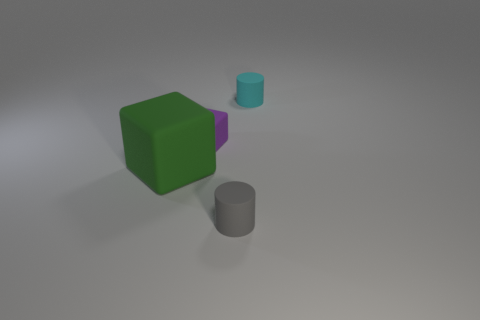Add 1 tiny metallic balls. How many objects exist? 5 Subtract 2 blocks. How many blocks are left? 0 Subtract all purple cylinders. Subtract all yellow blocks. How many cylinders are left? 2 Subtract all gray cylinders. How many green blocks are left? 1 Subtract all tiny cyan rubber cylinders. Subtract all large gray shiny cylinders. How many objects are left? 3 Add 4 cyan matte things. How many cyan matte things are left? 5 Add 3 big green blocks. How many big green blocks exist? 4 Subtract all cyan cylinders. How many cylinders are left? 1 Subtract 0 green balls. How many objects are left? 4 